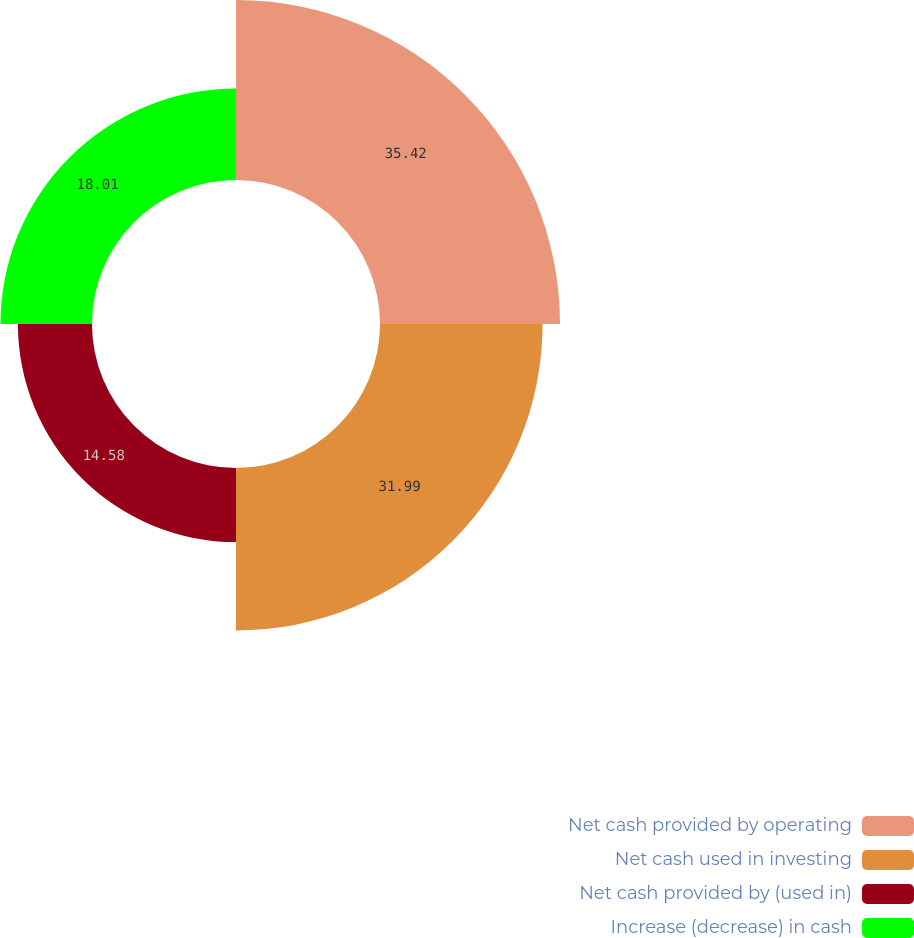Convert chart. <chart><loc_0><loc_0><loc_500><loc_500><pie_chart><fcel>Net cash provided by operating<fcel>Net cash used in investing<fcel>Net cash provided by (used in)<fcel>Increase (decrease) in cash<nl><fcel>35.42%<fcel>31.99%<fcel>14.58%<fcel>18.01%<nl></chart> 